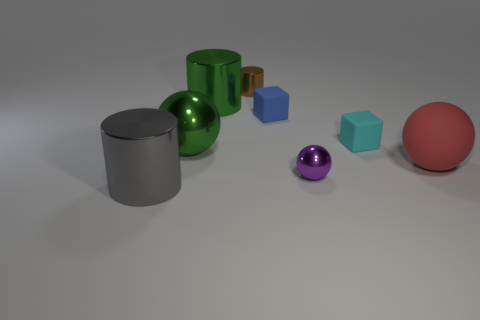Subtract all large red rubber spheres. How many spheres are left? 2 Add 1 tiny brown shiny things. How many objects exist? 9 Subtract 2 cubes. How many cubes are left? 0 Add 6 large rubber things. How many large rubber things exist? 7 Subtract all green cylinders. How many cylinders are left? 2 Subtract 1 red spheres. How many objects are left? 7 Subtract all cubes. How many objects are left? 6 Subtract all brown cylinders. Subtract all green spheres. How many cylinders are left? 2 Subtract all red balls. How many gray cylinders are left? 1 Subtract all purple metallic things. Subtract all large green metallic spheres. How many objects are left? 6 